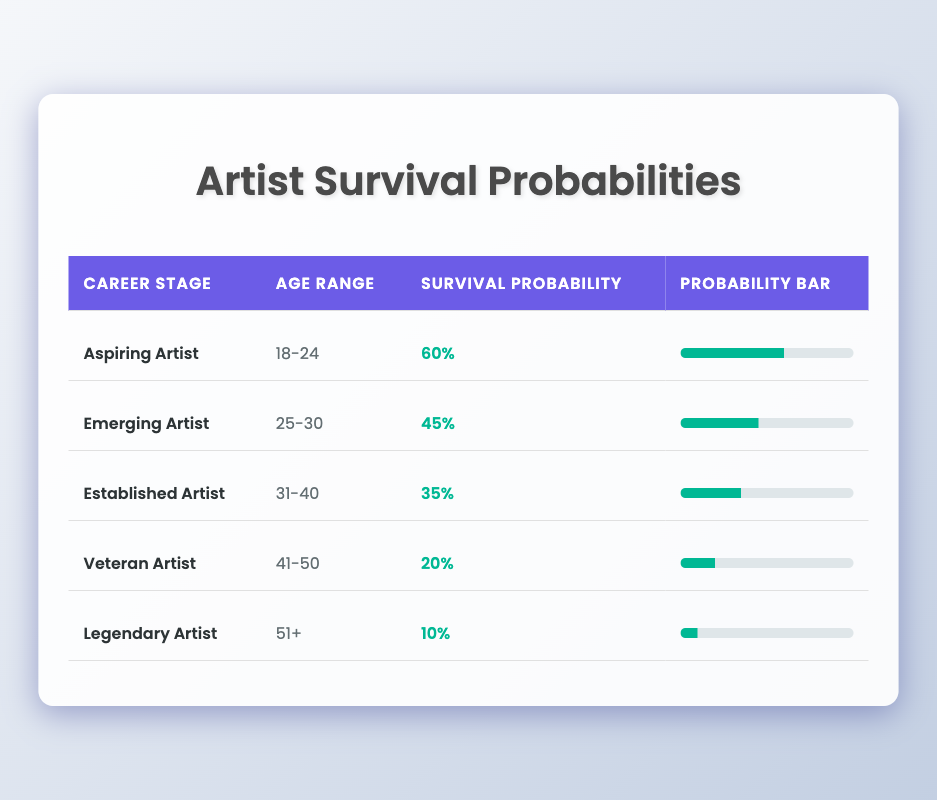What is the survival probability for Aspiring Artists? The survival probability for Aspiring Artists is specifically mentioned in the table as 60%.
Answer: 60% Which career stage has the lowest survival probability? By observing the table, we can see that the Legendary Artist career stage has the lowest survival probability at 10%.
Answer: Legendary Artist What is the average survival probability across all career stages? First, we add the survival probabilities: 60 + 45 + 35 + 20 + 10 = 170. Then, we divide this sum by the number of career stages, which is 5. So, 170 / 5 = 34%.
Answer: 34% Is the survival probability for Established Artists higher than for Veteran Artists? The survival probability for Established Artists is 35%, while for Veteran Artists, it is 20%. Since 35% is greater than 20%, the answer is yes.
Answer: Yes What are the differences in survival probabilities between each career stage? To find the differences: 
- Aspiring to Emerging: 60% - 45% = 15%
- Emerging to Established: 45% - 35% = 10%
- Established to Veteran: 35% - 20% = 15%
- Veteran to Legendary: 20% - 10% = 10%
We summarize the differences as: 15%, 10%, 15%, 10%.
Answer: 15%, 10%, 15%, 10% Are the survival probabilities decreasing as the career stages progress? Reviewing the survival probabilities, we observe: 60% (Aspiring) > 45% (Emerging) > 35% (Established) > 20% (Veteran) > 10% (Legendary). Therefore, they are indeed decreasing.
Answer: Yes What is the survival probability for the age range 41-50? According to the table, the survival probability for the age range 41-50, which corresponds to Veteran Artists, is 20%.
Answer: 20% What percentage drop occurs from Emerging Artists to Established Artists? The drop from Emerging Artists is 45% and Established Artists is 35%. The difference is 10%. To find the percentage drop: (10/45)*100 = 22.22%, so the drop is approximately 22%.
Answer: 22% 